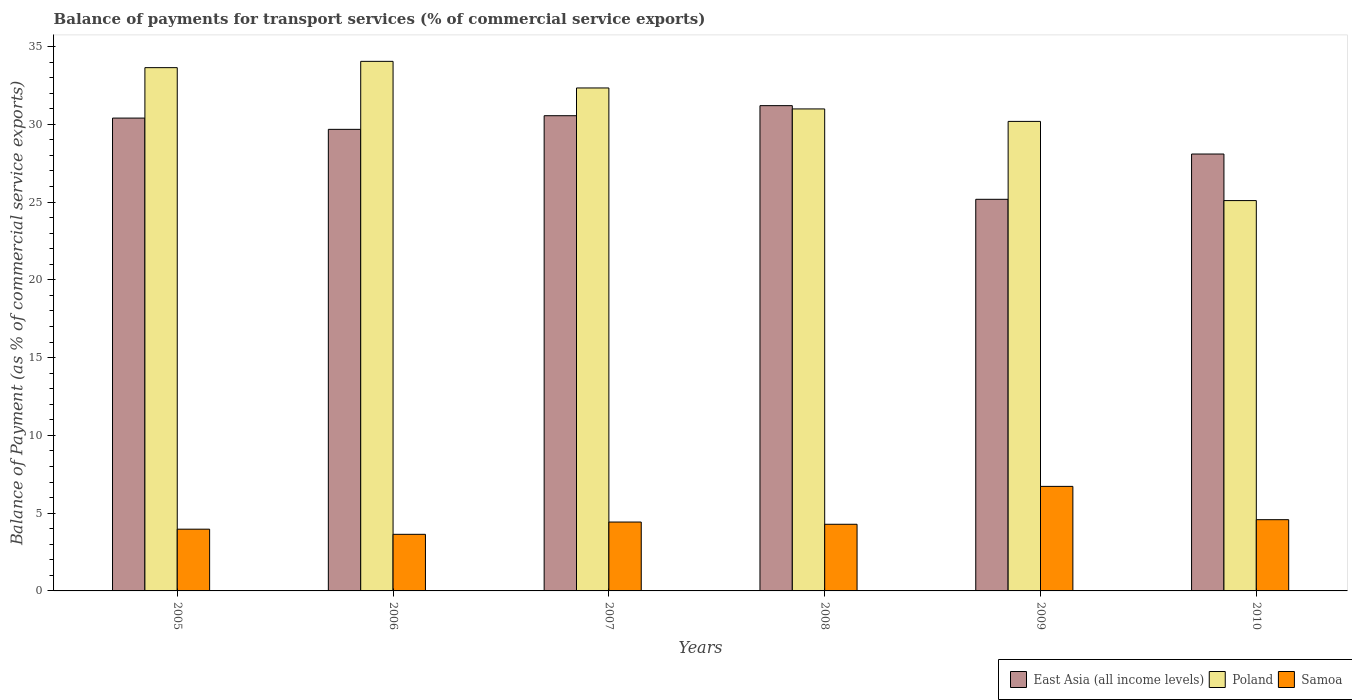How many different coloured bars are there?
Your answer should be very brief. 3. How many groups of bars are there?
Provide a succinct answer. 6. Are the number of bars per tick equal to the number of legend labels?
Ensure brevity in your answer.  Yes. Are the number of bars on each tick of the X-axis equal?
Offer a terse response. Yes. How many bars are there on the 2nd tick from the right?
Offer a very short reply. 3. What is the label of the 3rd group of bars from the left?
Your answer should be very brief. 2007. What is the balance of payments for transport services in East Asia (all income levels) in 2009?
Offer a terse response. 25.18. Across all years, what is the maximum balance of payments for transport services in Poland?
Give a very brief answer. 34.04. Across all years, what is the minimum balance of payments for transport services in Samoa?
Your answer should be compact. 3.64. In which year was the balance of payments for transport services in Poland minimum?
Provide a short and direct response. 2010. What is the total balance of payments for transport services in East Asia (all income levels) in the graph?
Offer a very short reply. 175.08. What is the difference between the balance of payments for transport services in Samoa in 2006 and that in 2009?
Your answer should be compact. -3.08. What is the difference between the balance of payments for transport services in East Asia (all income levels) in 2007 and the balance of payments for transport services in Samoa in 2009?
Your answer should be very brief. 23.83. What is the average balance of payments for transport services in Samoa per year?
Give a very brief answer. 4.6. In the year 2007, what is the difference between the balance of payments for transport services in East Asia (all income levels) and balance of payments for transport services in Samoa?
Provide a succinct answer. 26.12. In how many years, is the balance of payments for transport services in Poland greater than 17 %?
Make the answer very short. 6. What is the ratio of the balance of payments for transport services in Samoa in 2005 to that in 2010?
Provide a succinct answer. 0.87. What is the difference between the highest and the second highest balance of payments for transport services in Poland?
Keep it short and to the point. 0.4. What is the difference between the highest and the lowest balance of payments for transport services in Samoa?
Your answer should be compact. 3.08. In how many years, is the balance of payments for transport services in Samoa greater than the average balance of payments for transport services in Samoa taken over all years?
Your response must be concise. 1. What does the 3rd bar from the left in 2006 represents?
Your response must be concise. Samoa. What does the 1st bar from the right in 2009 represents?
Offer a terse response. Samoa. Is it the case that in every year, the sum of the balance of payments for transport services in Poland and balance of payments for transport services in Samoa is greater than the balance of payments for transport services in East Asia (all income levels)?
Offer a very short reply. Yes. How many bars are there?
Offer a very short reply. 18. How many years are there in the graph?
Offer a terse response. 6. What is the difference between two consecutive major ticks on the Y-axis?
Your answer should be very brief. 5. Are the values on the major ticks of Y-axis written in scientific E-notation?
Your response must be concise. No. Does the graph contain any zero values?
Offer a terse response. No. Where does the legend appear in the graph?
Your answer should be compact. Bottom right. How many legend labels are there?
Your answer should be very brief. 3. How are the legend labels stacked?
Keep it short and to the point. Horizontal. What is the title of the graph?
Make the answer very short. Balance of payments for transport services (% of commercial service exports). What is the label or title of the Y-axis?
Offer a terse response. Balance of Payment (as % of commercial service exports). What is the Balance of Payment (as % of commercial service exports) of East Asia (all income levels) in 2005?
Ensure brevity in your answer.  30.4. What is the Balance of Payment (as % of commercial service exports) in Poland in 2005?
Offer a very short reply. 33.64. What is the Balance of Payment (as % of commercial service exports) in Samoa in 2005?
Offer a very short reply. 3.97. What is the Balance of Payment (as % of commercial service exports) in East Asia (all income levels) in 2006?
Your response must be concise. 29.67. What is the Balance of Payment (as % of commercial service exports) of Poland in 2006?
Make the answer very short. 34.04. What is the Balance of Payment (as % of commercial service exports) in Samoa in 2006?
Make the answer very short. 3.64. What is the Balance of Payment (as % of commercial service exports) in East Asia (all income levels) in 2007?
Offer a terse response. 30.55. What is the Balance of Payment (as % of commercial service exports) in Poland in 2007?
Keep it short and to the point. 32.33. What is the Balance of Payment (as % of commercial service exports) in Samoa in 2007?
Your answer should be compact. 4.43. What is the Balance of Payment (as % of commercial service exports) of East Asia (all income levels) in 2008?
Provide a succinct answer. 31.2. What is the Balance of Payment (as % of commercial service exports) in Poland in 2008?
Give a very brief answer. 30.99. What is the Balance of Payment (as % of commercial service exports) of Samoa in 2008?
Give a very brief answer. 4.28. What is the Balance of Payment (as % of commercial service exports) of East Asia (all income levels) in 2009?
Provide a succinct answer. 25.18. What is the Balance of Payment (as % of commercial service exports) of Poland in 2009?
Your answer should be very brief. 30.18. What is the Balance of Payment (as % of commercial service exports) in Samoa in 2009?
Give a very brief answer. 6.72. What is the Balance of Payment (as % of commercial service exports) in East Asia (all income levels) in 2010?
Your answer should be compact. 28.09. What is the Balance of Payment (as % of commercial service exports) of Poland in 2010?
Ensure brevity in your answer.  25.09. What is the Balance of Payment (as % of commercial service exports) in Samoa in 2010?
Give a very brief answer. 4.58. Across all years, what is the maximum Balance of Payment (as % of commercial service exports) in East Asia (all income levels)?
Make the answer very short. 31.2. Across all years, what is the maximum Balance of Payment (as % of commercial service exports) of Poland?
Offer a very short reply. 34.04. Across all years, what is the maximum Balance of Payment (as % of commercial service exports) of Samoa?
Your answer should be compact. 6.72. Across all years, what is the minimum Balance of Payment (as % of commercial service exports) of East Asia (all income levels)?
Offer a terse response. 25.18. Across all years, what is the minimum Balance of Payment (as % of commercial service exports) of Poland?
Keep it short and to the point. 25.09. Across all years, what is the minimum Balance of Payment (as % of commercial service exports) in Samoa?
Provide a succinct answer. 3.64. What is the total Balance of Payment (as % of commercial service exports) of East Asia (all income levels) in the graph?
Offer a terse response. 175.08. What is the total Balance of Payment (as % of commercial service exports) of Poland in the graph?
Provide a short and direct response. 186.28. What is the total Balance of Payment (as % of commercial service exports) in Samoa in the graph?
Your answer should be compact. 27.62. What is the difference between the Balance of Payment (as % of commercial service exports) in East Asia (all income levels) in 2005 and that in 2006?
Give a very brief answer. 0.72. What is the difference between the Balance of Payment (as % of commercial service exports) of Poland in 2005 and that in 2006?
Offer a very short reply. -0.4. What is the difference between the Balance of Payment (as % of commercial service exports) in Samoa in 2005 and that in 2006?
Offer a very short reply. 0.33. What is the difference between the Balance of Payment (as % of commercial service exports) in East Asia (all income levels) in 2005 and that in 2007?
Ensure brevity in your answer.  -0.15. What is the difference between the Balance of Payment (as % of commercial service exports) in Poland in 2005 and that in 2007?
Make the answer very short. 1.31. What is the difference between the Balance of Payment (as % of commercial service exports) of Samoa in 2005 and that in 2007?
Provide a short and direct response. -0.46. What is the difference between the Balance of Payment (as % of commercial service exports) in East Asia (all income levels) in 2005 and that in 2008?
Make the answer very short. -0.8. What is the difference between the Balance of Payment (as % of commercial service exports) of Poland in 2005 and that in 2008?
Your answer should be compact. 2.65. What is the difference between the Balance of Payment (as % of commercial service exports) of Samoa in 2005 and that in 2008?
Keep it short and to the point. -0.32. What is the difference between the Balance of Payment (as % of commercial service exports) of East Asia (all income levels) in 2005 and that in 2009?
Offer a very short reply. 5.22. What is the difference between the Balance of Payment (as % of commercial service exports) of Poland in 2005 and that in 2009?
Keep it short and to the point. 3.46. What is the difference between the Balance of Payment (as % of commercial service exports) of Samoa in 2005 and that in 2009?
Your response must be concise. -2.75. What is the difference between the Balance of Payment (as % of commercial service exports) of East Asia (all income levels) in 2005 and that in 2010?
Your answer should be very brief. 2.31. What is the difference between the Balance of Payment (as % of commercial service exports) in Poland in 2005 and that in 2010?
Make the answer very short. 8.55. What is the difference between the Balance of Payment (as % of commercial service exports) of Samoa in 2005 and that in 2010?
Provide a short and direct response. -0.61. What is the difference between the Balance of Payment (as % of commercial service exports) of East Asia (all income levels) in 2006 and that in 2007?
Ensure brevity in your answer.  -0.88. What is the difference between the Balance of Payment (as % of commercial service exports) in Poland in 2006 and that in 2007?
Your answer should be compact. 1.71. What is the difference between the Balance of Payment (as % of commercial service exports) of Samoa in 2006 and that in 2007?
Provide a succinct answer. -0.79. What is the difference between the Balance of Payment (as % of commercial service exports) in East Asia (all income levels) in 2006 and that in 2008?
Ensure brevity in your answer.  -1.52. What is the difference between the Balance of Payment (as % of commercial service exports) of Poland in 2006 and that in 2008?
Provide a succinct answer. 3.06. What is the difference between the Balance of Payment (as % of commercial service exports) in Samoa in 2006 and that in 2008?
Make the answer very short. -0.65. What is the difference between the Balance of Payment (as % of commercial service exports) of East Asia (all income levels) in 2006 and that in 2009?
Your response must be concise. 4.5. What is the difference between the Balance of Payment (as % of commercial service exports) in Poland in 2006 and that in 2009?
Keep it short and to the point. 3.86. What is the difference between the Balance of Payment (as % of commercial service exports) of Samoa in 2006 and that in 2009?
Your answer should be compact. -3.08. What is the difference between the Balance of Payment (as % of commercial service exports) in East Asia (all income levels) in 2006 and that in 2010?
Your response must be concise. 1.59. What is the difference between the Balance of Payment (as % of commercial service exports) of Poland in 2006 and that in 2010?
Your response must be concise. 8.95. What is the difference between the Balance of Payment (as % of commercial service exports) in Samoa in 2006 and that in 2010?
Offer a very short reply. -0.94. What is the difference between the Balance of Payment (as % of commercial service exports) in East Asia (all income levels) in 2007 and that in 2008?
Offer a very short reply. -0.65. What is the difference between the Balance of Payment (as % of commercial service exports) in Poland in 2007 and that in 2008?
Keep it short and to the point. 1.35. What is the difference between the Balance of Payment (as % of commercial service exports) of Samoa in 2007 and that in 2008?
Keep it short and to the point. 0.14. What is the difference between the Balance of Payment (as % of commercial service exports) in East Asia (all income levels) in 2007 and that in 2009?
Your answer should be very brief. 5.37. What is the difference between the Balance of Payment (as % of commercial service exports) in Poland in 2007 and that in 2009?
Offer a terse response. 2.15. What is the difference between the Balance of Payment (as % of commercial service exports) in Samoa in 2007 and that in 2009?
Your answer should be very brief. -2.29. What is the difference between the Balance of Payment (as % of commercial service exports) of East Asia (all income levels) in 2007 and that in 2010?
Your answer should be very brief. 2.46. What is the difference between the Balance of Payment (as % of commercial service exports) of Poland in 2007 and that in 2010?
Offer a very short reply. 7.24. What is the difference between the Balance of Payment (as % of commercial service exports) in Samoa in 2007 and that in 2010?
Offer a very short reply. -0.15. What is the difference between the Balance of Payment (as % of commercial service exports) in East Asia (all income levels) in 2008 and that in 2009?
Make the answer very short. 6.02. What is the difference between the Balance of Payment (as % of commercial service exports) in Poland in 2008 and that in 2009?
Your response must be concise. 0.8. What is the difference between the Balance of Payment (as % of commercial service exports) in Samoa in 2008 and that in 2009?
Your answer should be very brief. -2.44. What is the difference between the Balance of Payment (as % of commercial service exports) in East Asia (all income levels) in 2008 and that in 2010?
Give a very brief answer. 3.11. What is the difference between the Balance of Payment (as % of commercial service exports) in Poland in 2008 and that in 2010?
Keep it short and to the point. 5.89. What is the difference between the Balance of Payment (as % of commercial service exports) in Samoa in 2008 and that in 2010?
Offer a terse response. -0.3. What is the difference between the Balance of Payment (as % of commercial service exports) in East Asia (all income levels) in 2009 and that in 2010?
Give a very brief answer. -2.91. What is the difference between the Balance of Payment (as % of commercial service exports) of Poland in 2009 and that in 2010?
Your response must be concise. 5.09. What is the difference between the Balance of Payment (as % of commercial service exports) in Samoa in 2009 and that in 2010?
Ensure brevity in your answer.  2.14. What is the difference between the Balance of Payment (as % of commercial service exports) of East Asia (all income levels) in 2005 and the Balance of Payment (as % of commercial service exports) of Poland in 2006?
Your answer should be very brief. -3.65. What is the difference between the Balance of Payment (as % of commercial service exports) in East Asia (all income levels) in 2005 and the Balance of Payment (as % of commercial service exports) in Samoa in 2006?
Your answer should be very brief. 26.76. What is the difference between the Balance of Payment (as % of commercial service exports) of Poland in 2005 and the Balance of Payment (as % of commercial service exports) of Samoa in 2006?
Give a very brief answer. 30. What is the difference between the Balance of Payment (as % of commercial service exports) of East Asia (all income levels) in 2005 and the Balance of Payment (as % of commercial service exports) of Poland in 2007?
Provide a succinct answer. -1.94. What is the difference between the Balance of Payment (as % of commercial service exports) in East Asia (all income levels) in 2005 and the Balance of Payment (as % of commercial service exports) in Samoa in 2007?
Your response must be concise. 25.97. What is the difference between the Balance of Payment (as % of commercial service exports) of Poland in 2005 and the Balance of Payment (as % of commercial service exports) of Samoa in 2007?
Keep it short and to the point. 29.21. What is the difference between the Balance of Payment (as % of commercial service exports) of East Asia (all income levels) in 2005 and the Balance of Payment (as % of commercial service exports) of Poland in 2008?
Provide a succinct answer. -0.59. What is the difference between the Balance of Payment (as % of commercial service exports) in East Asia (all income levels) in 2005 and the Balance of Payment (as % of commercial service exports) in Samoa in 2008?
Provide a succinct answer. 26.11. What is the difference between the Balance of Payment (as % of commercial service exports) of Poland in 2005 and the Balance of Payment (as % of commercial service exports) of Samoa in 2008?
Your answer should be compact. 29.36. What is the difference between the Balance of Payment (as % of commercial service exports) in East Asia (all income levels) in 2005 and the Balance of Payment (as % of commercial service exports) in Poland in 2009?
Make the answer very short. 0.21. What is the difference between the Balance of Payment (as % of commercial service exports) of East Asia (all income levels) in 2005 and the Balance of Payment (as % of commercial service exports) of Samoa in 2009?
Make the answer very short. 23.68. What is the difference between the Balance of Payment (as % of commercial service exports) of Poland in 2005 and the Balance of Payment (as % of commercial service exports) of Samoa in 2009?
Your answer should be compact. 26.92. What is the difference between the Balance of Payment (as % of commercial service exports) of East Asia (all income levels) in 2005 and the Balance of Payment (as % of commercial service exports) of Poland in 2010?
Keep it short and to the point. 5.3. What is the difference between the Balance of Payment (as % of commercial service exports) of East Asia (all income levels) in 2005 and the Balance of Payment (as % of commercial service exports) of Samoa in 2010?
Offer a terse response. 25.82. What is the difference between the Balance of Payment (as % of commercial service exports) of Poland in 2005 and the Balance of Payment (as % of commercial service exports) of Samoa in 2010?
Your response must be concise. 29.06. What is the difference between the Balance of Payment (as % of commercial service exports) in East Asia (all income levels) in 2006 and the Balance of Payment (as % of commercial service exports) in Poland in 2007?
Provide a short and direct response. -2.66. What is the difference between the Balance of Payment (as % of commercial service exports) in East Asia (all income levels) in 2006 and the Balance of Payment (as % of commercial service exports) in Samoa in 2007?
Make the answer very short. 25.25. What is the difference between the Balance of Payment (as % of commercial service exports) of Poland in 2006 and the Balance of Payment (as % of commercial service exports) of Samoa in 2007?
Ensure brevity in your answer.  29.62. What is the difference between the Balance of Payment (as % of commercial service exports) of East Asia (all income levels) in 2006 and the Balance of Payment (as % of commercial service exports) of Poland in 2008?
Your answer should be very brief. -1.31. What is the difference between the Balance of Payment (as % of commercial service exports) in East Asia (all income levels) in 2006 and the Balance of Payment (as % of commercial service exports) in Samoa in 2008?
Provide a succinct answer. 25.39. What is the difference between the Balance of Payment (as % of commercial service exports) in Poland in 2006 and the Balance of Payment (as % of commercial service exports) in Samoa in 2008?
Provide a succinct answer. 29.76. What is the difference between the Balance of Payment (as % of commercial service exports) in East Asia (all income levels) in 2006 and the Balance of Payment (as % of commercial service exports) in Poland in 2009?
Offer a very short reply. -0.51. What is the difference between the Balance of Payment (as % of commercial service exports) of East Asia (all income levels) in 2006 and the Balance of Payment (as % of commercial service exports) of Samoa in 2009?
Provide a succinct answer. 22.95. What is the difference between the Balance of Payment (as % of commercial service exports) in Poland in 2006 and the Balance of Payment (as % of commercial service exports) in Samoa in 2009?
Offer a terse response. 27.32. What is the difference between the Balance of Payment (as % of commercial service exports) in East Asia (all income levels) in 2006 and the Balance of Payment (as % of commercial service exports) in Poland in 2010?
Keep it short and to the point. 4.58. What is the difference between the Balance of Payment (as % of commercial service exports) of East Asia (all income levels) in 2006 and the Balance of Payment (as % of commercial service exports) of Samoa in 2010?
Your answer should be compact. 25.09. What is the difference between the Balance of Payment (as % of commercial service exports) of Poland in 2006 and the Balance of Payment (as % of commercial service exports) of Samoa in 2010?
Provide a short and direct response. 29.46. What is the difference between the Balance of Payment (as % of commercial service exports) in East Asia (all income levels) in 2007 and the Balance of Payment (as % of commercial service exports) in Poland in 2008?
Your response must be concise. -0.44. What is the difference between the Balance of Payment (as % of commercial service exports) in East Asia (all income levels) in 2007 and the Balance of Payment (as % of commercial service exports) in Samoa in 2008?
Make the answer very short. 26.27. What is the difference between the Balance of Payment (as % of commercial service exports) of Poland in 2007 and the Balance of Payment (as % of commercial service exports) of Samoa in 2008?
Keep it short and to the point. 28.05. What is the difference between the Balance of Payment (as % of commercial service exports) of East Asia (all income levels) in 2007 and the Balance of Payment (as % of commercial service exports) of Poland in 2009?
Provide a short and direct response. 0.37. What is the difference between the Balance of Payment (as % of commercial service exports) in East Asia (all income levels) in 2007 and the Balance of Payment (as % of commercial service exports) in Samoa in 2009?
Your response must be concise. 23.83. What is the difference between the Balance of Payment (as % of commercial service exports) of Poland in 2007 and the Balance of Payment (as % of commercial service exports) of Samoa in 2009?
Your response must be concise. 25.61. What is the difference between the Balance of Payment (as % of commercial service exports) in East Asia (all income levels) in 2007 and the Balance of Payment (as % of commercial service exports) in Poland in 2010?
Provide a short and direct response. 5.46. What is the difference between the Balance of Payment (as % of commercial service exports) in East Asia (all income levels) in 2007 and the Balance of Payment (as % of commercial service exports) in Samoa in 2010?
Offer a terse response. 25.97. What is the difference between the Balance of Payment (as % of commercial service exports) of Poland in 2007 and the Balance of Payment (as % of commercial service exports) of Samoa in 2010?
Provide a succinct answer. 27.75. What is the difference between the Balance of Payment (as % of commercial service exports) in East Asia (all income levels) in 2008 and the Balance of Payment (as % of commercial service exports) in Poland in 2009?
Provide a succinct answer. 1.01. What is the difference between the Balance of Payment (as % of commercial service exports) in East Asia (all income levels) in 2008 and the Balance of Payment (as % of commercial service exports) in Samoa in 2009?
Make the answer very short. 24.48. What is the difference between the Balance of Payment (as % of commercial service exports) in Poland in 2008 and the Balance of Payment (as % of commercial service exports) in Samoa in 2009?
Provide a succinct answer. 24.27. What is the difference between the Balance of Payment (as % of commercial service exports) of East Asia (all income levels) in 2008 and the Balance of Payment (as % of commercial service exports) of Poland in 2010?
Provide a short and direct response. 6.1. What is the difference between the Balance of Payment (as % of commercial service exports) of East Asia (all income levels) in 2008 and the Balance of Payment (as % of commercial service exports) of Samoa in 2010?
Your answer should be compact. 26.62. What is the difference between the Balance of Payment (as % of commercial service exports) of Poland in 2008 and the Balance of Payment (as % of commercial service exports) of Samoa in 2010?
Give a very brief answer. 26.41. What is the difference between the Balance of Payment (as % of commercial service exports) in East Asia (all income levels) in 2009 and the Balance of Payment (as % of commercial service exports) in Poland in 2010?
Give a very brief answer. 0.08. What is the difference between the Balance of Payment (as % of commercial service exports) in East Asia (all income levels) in 2009 and the Balance of Payment (as % of commercial service exports) in Samoa in 2010?
Provide a succinct answer. 20.6. What is the difference between the Balance of Payment (as % of commercial service exports) of Poland in 2009 and the Balance of Payment (as % of commercial service exports) of Samoa in 2010?
Ensure brevity in your answer.  25.6. What is the average Balance of Payment (as % of commercial service exports) in East Asia (all income levels) per year?
Your answer should be very brief. 29.18. What is the average Balance of Payment (as % of commercial service exports) of Poland per year?
Keep it short and to the point. 31.05. What is the average Balance of Payment (as % of commercial service exports) in Samoa per year?
Keep it short and to the point. 4.6. In the year 2005, what is the difference between the Balance of Payment (as % of commercial service exports) in East Asia (all income levels) and Balance of Payment (as % of commercial service exports) in Poland?
Your answer should be very brief. -3.24. In the year 2005, what is the difference between the Balance of Payment (as % of commercial service exports) of East Asia (all income levels) and Balance of Payment (as % of commercial service exports) of Samoa?
Give a very brief answer. 26.43. In the year 2005, what is the difference between the Balance of Payment (as % of commercial service exports) of Poland and Balance of Payment (as % of commercial service exports) of Samoa?
Your answer should be very brief. 29.67. In the year 2006, what is the difference between the Balance of Payment (as % of commercial service exports) of East Asia (all income levels) and Balance of Payment (as % of commercial service exports) of Poland?
Make the answer very short. -4.37. In the year 2006, what is the difference between the Balance of Payment (as % of commercial service exports) in East Asia (all income levels) and Balance of Payment (as % of commercial service exports) in Samoa?
Offer a very short reply. 26.03. In the year 2006, what is the difference between the Balance of Payment (as % of commercial service exports) of Poland and Balance of Payment (as % of commercial service exports) of Samoa?
Keep it short and to the point. 30.4. In the year 2007, what is the difference between the Balance of Payment (as % of commercial service exports) of East Asia (all income levels) and Balance of Payment (as % of commercial service exports) of Poland?
Ensure brevity in your answer.  -1.78. In the year 2007, what is the difference between the Balance of Payment (as % of commercial service exports) in East Asia (all income levels) and Balance of Payment (as % of commercial service exports) in Samoa?
Ensure brevity in your answer.  26.12. In the year 2007, what is the difference between the Balance of Payment (as % of commercial service exports) of Poland and Balance of Payment (as % of commercial service exports) of Samoa?
Give a very brief answer. 27.91. In the year 2008, what is the difference between the Balance of Payment (as % of commercial service exports) of East Asia (all income levels) and Balance of Payment (as % of commercial service exports) of Poland?
Ensure brevity in your answer.  0.21. In the year 2008, what is the difference between the Balance of Payment (as % of commercial service exports) of East Asia (all income levels) and Balance of Payment (as % of commercial service exports) of Samoa?
Make the answer very short. 26.91. In the year 2008, what is the difference between the Balance of Payment (as % of commercial service exports) in Poland and Balance of Payment (as % of commercial service exports) in Samoa?
Provide a short and direct response. 26.7. In the year 2009, what is the difference between the Balance of Payment (as % of commercial service exports) in East Asia (all income levels) and Balance of Payment (as % of commercial service exports) in Poland?
Make the answer very short. -5.01. In the year 2009, what is the difference between the Balance of Payment (as % of commercial service exports) of East Asia (all income levels) and Balance of Payment (as % of commercial service exports) of Samoa?
Make the answer very short. 18.46. In the year 2009, what is the difference between the Balance of Payment (as % of commercial service exports) in Poland and Balance of Payment (as % of commercial service exports) in Samoa?
Ensure brevity in your answer.  23.46. In the year 2010, what is the difference between the Balance of Payment (as % of commercial service exports) of East Asia (all income levels) and Balance of Payment (as % of commercial service exports) of Poland?
Make the answer very short. 2.99. In the year 2010, what is the difference between the Balance of Payment (as % of commercial service exports) of East Asia (all income levels) and Balance of Payment (as % of commercial service exports) of Samoa?
Provide a succinct answer. 23.51. In the year 2010, what is the difference between the Balance of Payment (as % of commercial service exports) of Poland and Balance of Payment (as % of commercial service exports) of Samoa?
Make the answer very short. 20.51. What is the ratio of the Balance of Payment (as % of commercial service exports) of East Asia (all income levels) in 2005 to that in 2006?
Offer a terse response. 1.02. What is the ratio of the Balance of Payment (as % of commercial service exports) in Samoa in 2005 to that in 2006?
Ensure brevity in your answer.  1.09. What is the ratio of the Balance of Payment (as % of commercial service exports) of East Asia (all income levels) in 2005 to that in 2007?
Make the answer very short. 0.99. What is the ratio of the Balance of Payment (as % of commercial service exports) in Poland in 2005 to that in 2007?
Give a very brief answer. 1.04. What is the ratio of the Balance of Payment (as % of commercial service exports) in Samoa in 2005 to that in 2007?
Offer a very short reply. 0.9. What is the ratio of the Balance of Payment (as % of commercial service exports) of East Asia (all income levels) in 2005 to that in 2008?
Keep it short and to the point. 0.97. What is the ratio of the Balance of Payment (as % of commercial service exports) in Poland in 2005 to that in 2008?
Make the answer very short. 1.09. What is the ratio of the Balance of Payment (as % of commercial service exports) in Samoa in 2005 to that in 2008?
Provide a succinct answer. 0.93. What is the ratio of the Balance of Payment (as % of commercial service exports) of East Asia (all income levels) in 2005 to that in 2009?
Provide a short and direct response. 1.21. What is the ratio of the Balance of Payment (as % of commercial service exports) of Poland in 2005 to that in 2009?
Offer a very short reply. 1.11. What is the ratio of the Balance of Payment (as % of commercial service exports) in Samoa in 2005 to that in 2009?
Give a very brief answer. 0.59. What is the ratio of the Balance of Payment (as % of commercial service exports) in East Asia (all income levels) in 2005 to that in 2010?
Make the answer very short. 1.08. What is the ratio of the Balance of Payment (as % of commercial service exports) in Poland in 2005 to that in 2010?
Give a very brief answer. 1.34. What is the ratio of the Balance of Payment (as % of commercial service exports) of Samoa in 2005 to that in 2010?
Provide a succinct answer. 0.87. What is the ratio of the Balance of Payment (as % of commercial service exports) of East Asia (all income levels) in 2006 to that in 2007?
Your response must be concise. 0.97. What is the ratio of the Balance of Payment (as % of commercial service exports) of Poland in 2006 to that in 2007?
Ensure brevity in your answer.  1.05. What is the ratio of the Balance of Payment (as % of commercial service exports) in Samoa in 2006 to that in 2007?
Give a very brief answer. 0.82. What is the ratio of the Balance of Payment (as % of commercial service exports) of East Asia (all income levels) in 2006 to that in 2008?
Offer a terse response. 0.95. What is the ratio of the Balance of Payment (as % of commercial service exports) in Poland in 2006 to that in 2008?
Your answer should be very brief. 1.1. What is the ratio of the Balance of Payment (as % of commercial service exports) in Samoa in 2006 to that in 2008?
Offer a very short reply. 0.85. What is the ratio of the Balance of Payment (as % of commercial service exports) of East Asia (all income levels) in 2006 to that in 2009?
Provide a succinct answer. 1.18. What is the ratio of the Balance of Payment (as % of commercial service exports) of Poland in 2006 to that in 2009?
Offer a terse response. 1.13. What is the ratio of the Balance of Payment (as % of commercial service exports) of Samoa in 2006 to that in 2009?
Your answer should be very brief. 0.54. What is the ratio of the Balance of Payment (as % of commercial service exports) in East Asia (all income levels) in 2006 to that in 2010?
Keep it short and to the point. 1.06. What is the ratio of the Balance of Payment (as % of commercial service exports) of Poland in 2006 to that in 2010?
Give a very brief answer. 1.36. What is the ratio of the Balance of Payment (as % of commercial service exports) in Samoa in 2006 to that in 2010?
Provide a succinct answer. 0.79. What is the ratio of the Balance of Payment (as % of commercial service exports) in East Asia (all income levels) in 2007 to that in 2008?
Offer a very short reply. 0.98. What is the ratio of the Balance of Payment (as % of commercial service exports) of Poland in 2007 to that in 2008?
Your answer should be compact. 1.04. What is the ratio of the Balance of Payment (as % of commercial service exports) of Samoa in 2007 to that in 2008?
Make the answer very short. 1.03. What is the ratio of the Balance of Payment (as % of commercial service exports) in East Asia (all income levels) in 2007 to that in 2009?
Your answer should be compact. 1.21. What is the ratio of the Balance of Payment (as % of commercial service exports) of Poland in 2007 to that in 2009?
Your answer should be compact. 1.07. What is the ratio of the Balance of Payment (as % of commercial service exports) of Samoa in 2007 to that in 2009?
Your response must be concise. 0.66. What is the ratio of the Balance of Payment (as % of commercial service exports) in East Asia (all income levels) in 2007 to that in 2010?
Offer a very short reply. 1.09. What is the ratio of the Balance of Payment (as % of commercial service exports) in Poland in 2007 to that in 2010?
Make the answer very short. 1.29. What is the ratio of the Balance of Payment (as % of commercial service exports) in Samoa in 2007 to that in 2010?
Your response must be concise. 0.97. What is the ratio of the Balance of Payment (as % of commercial service exports) in East Asia (all income levels) in 2008 to that in 2009?
Your response must be concise. 1.24. What is the ratio of the Balance of Payment (as % of commercial service exports) of Poland in 2008 to that in 2009?
Provide a succinct answer. 1.03. What is the ratio of the Balance of Payment (as % of commercial service exports) in Samoa in 2008 to that in 2009?
Provide a succinct answer. 0.64. What is the ratio of the Balance of Payment (as % of commercial service exports) of East Asia (all income levels) in 2008 to that in 2010?
Give a very brief answer. 1.11. What is the ratio of the Balance of Payment (as % of commercial service exports) of Poland in 2008 to that in 2010?
Your answer should be very brief. 1.23. What is the ratio of the Balance of Payment (as % of commercial service exports) in Samoa in 2008 to that in 2010?
Provide a short and direct response. 0.94. What is the ratio of the Balance of Payment (as % of commercial service exports) of East Asia (all income levels) in 2009 to that in 2010?
Your answer should be compact. 0.9. What is the ratio of the Balance of Payment (as % of commercial service exports) in Poland in 2009 to that in 2010?
Offer a terse response. 1.2. What is the ratio of the Balance of Payment (as % of commercial service exports) in Samoa in 2009 to that in 2010?
Provide a short and direct response. 1.47. What is the difference between the highest and the second highest Balance of Payment (as % of commercial service exports) in East Asia (all income levels)?
Your answer should be compact. 0.65. What is the difference between the highest and the second highest Balance of Payment (as % of commercial service exports) of Poland?
Provide a succinct answer. 0.4. What is the difference between the highest and the second highest Balance of Payment (as % of commercial service exports) in Samoa?
Your answer should be compact. 2.14. What is the difference between the highest and the lowest Balance of Payment (as % of commercial service exports) of East Asia (all income levels)?
Offer a terse response. 6.02. What is the difference between the highest and the lowest Balance of Payment (as % of commercial service exports) in Poland?
Give a very brief answer. 8.95. What is the difference between the highest and the lowest Balance of Payment (as % of commercial service exports) in Samoa?
Make the answer very short. 3.08. 